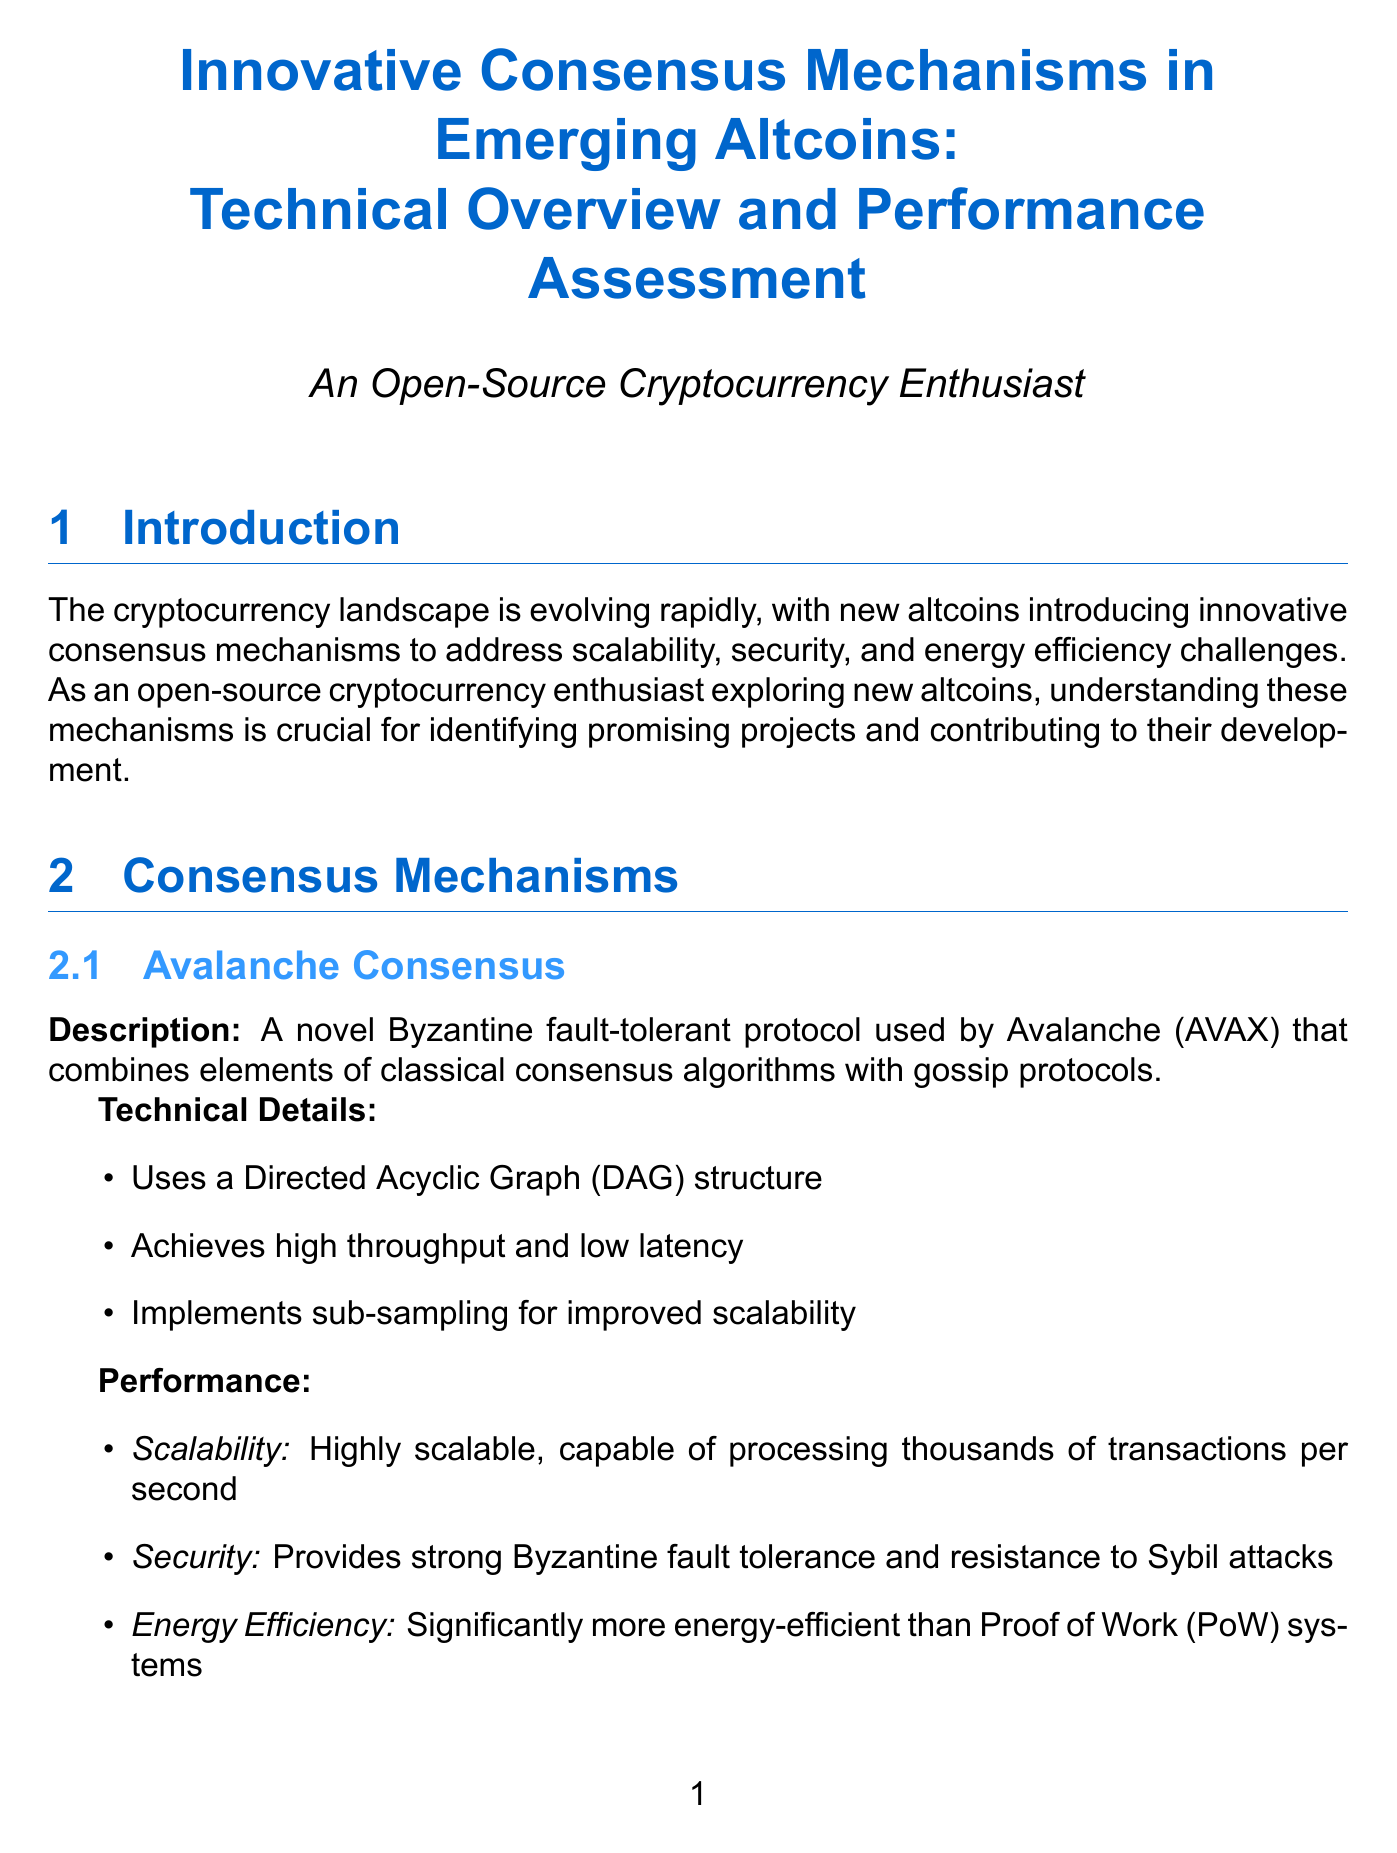What is the title of the report? The title of the report is mentioned at the beginning of the document.
Answer: Innovative Consensus Mechanisms in Emerging Altcoins: Technical Overview and Performance Assessment What consensus mechanism does Avalanche (AVAX) use? The consensus mechanism used by Avalanche is described under its section in the document.
Answer: Avalanche Consensus How does Ouroboros Praos improve upon the original Ouroboros? The improvement of Ouroboros Praos is noted in its description within the document.
Answer: It is a Proof-of-Stake protocol What is the scalability capability of Avalanche Consensus? The scalability capability of Avalanche Consensus is specified in the performance section.
Answer: Capable of processing thousands of transactions per second What unique feature does Solana (SOL) incorporate? The unique feature of Solana is outlined in the implementation examples section.
Answer: Proof of History (PoH) with Tower BFT Which consensus mechanism provides instant finality for transactions? The mechanism that provides instant finality is detailed under its description in the document.
Answer: Tendermint Core What is the energy efficiency comparison between the consensus mechanisms? The comparison of energy efficiency is discussed in the comparative analysis section.
Answer: All mechanisms are significantly more energy-efficient than traditional PoW systems Which altcoin uses Pure Proof of Stake (PPoS)? The document explicitly states which altcoin uses Pure Proof of Stake.
Answer: Algorand (ALGO) What future trend does the report mention regarding consensus mechanisms? Future trends discussed in the document highlight potential developments in the field.
Answer: Integration of Layer 2 scaling solutions with innovative consensus mechanisms 